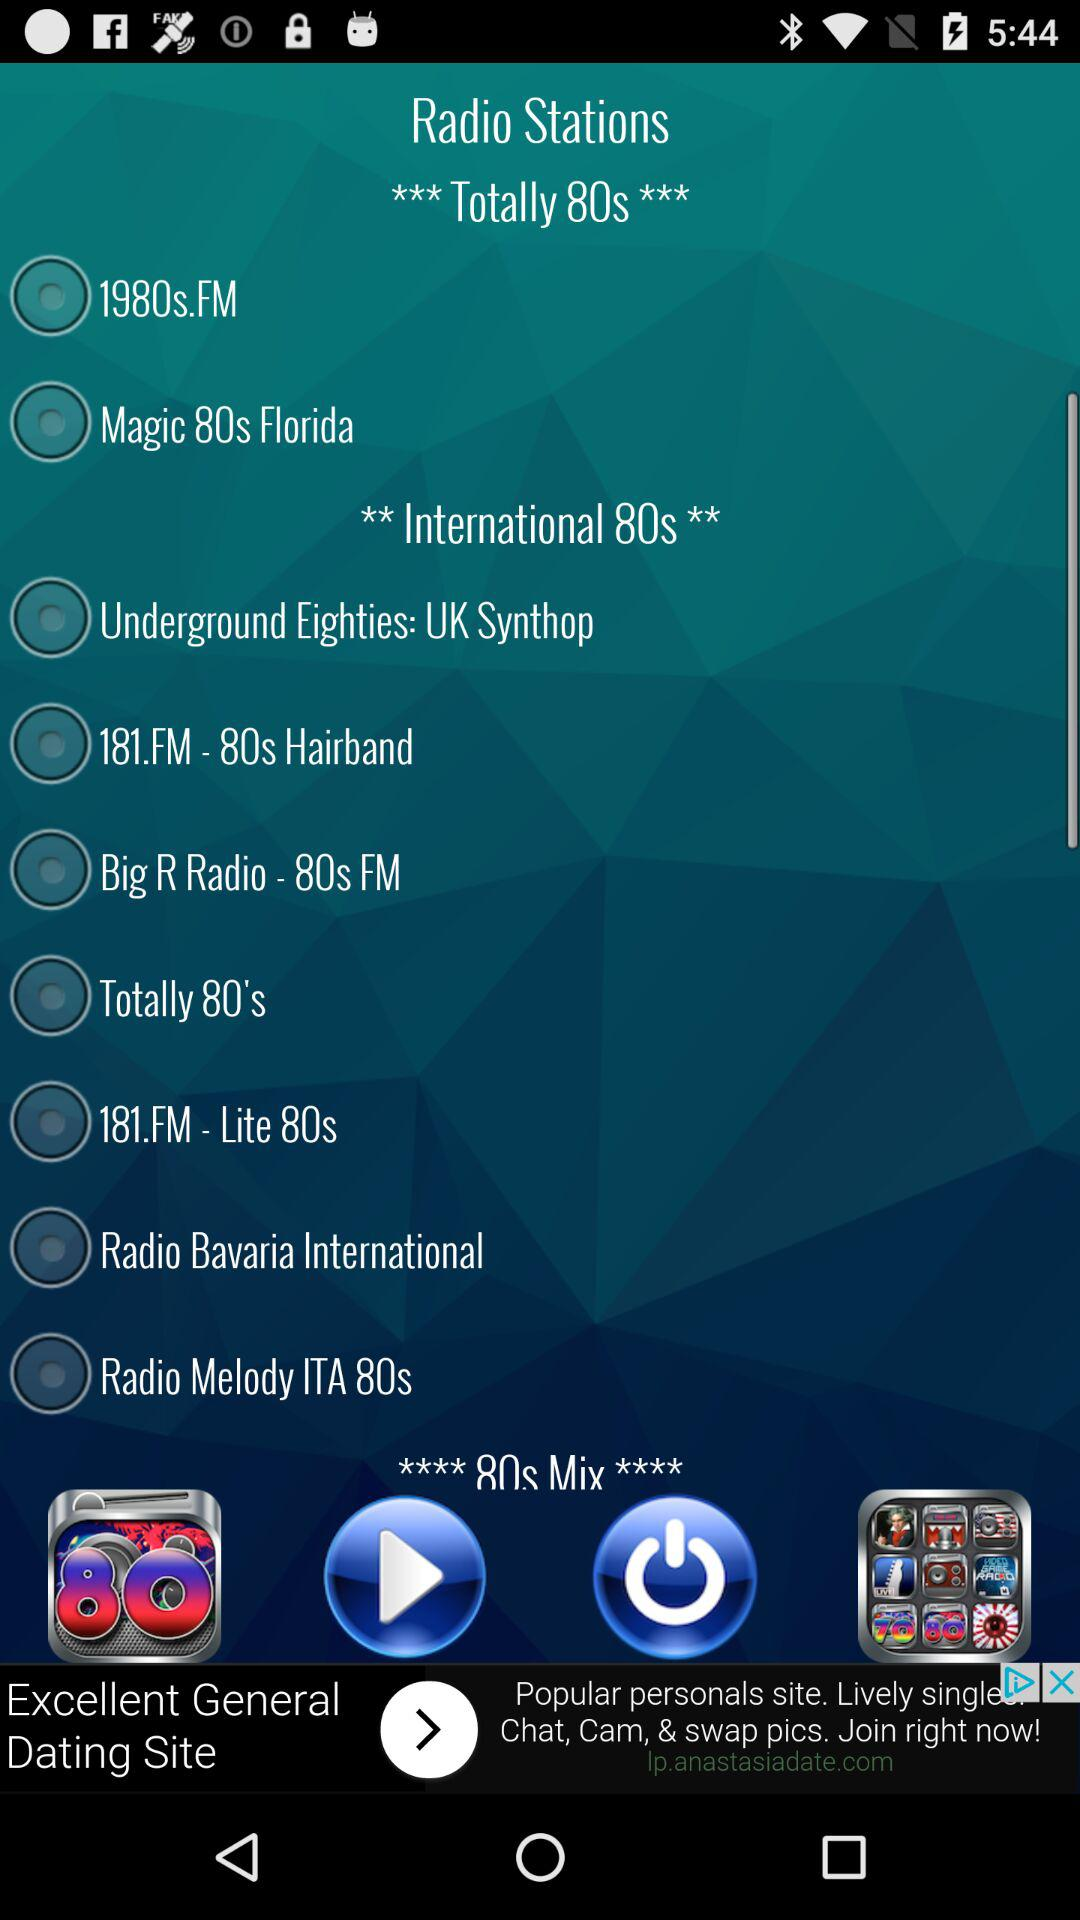What are the various "Totally 80s" radio stations? The radio stations are "1980s.FM" and "Magic 80s Florida". 